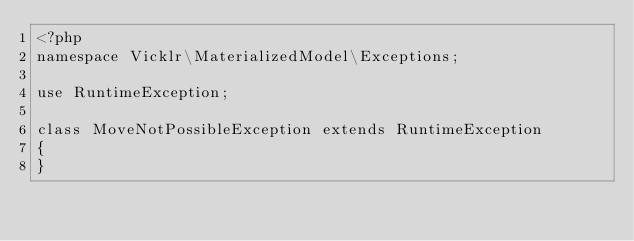<code> <loc_0><loc_0><loc_500><loc_500><_PHP_><?php
namespace Vicklr\MaterializedModel\Exceptions;

use RuntimeException;

class MoveNotPossibleException extends RuntimeException
{
}
</code> 